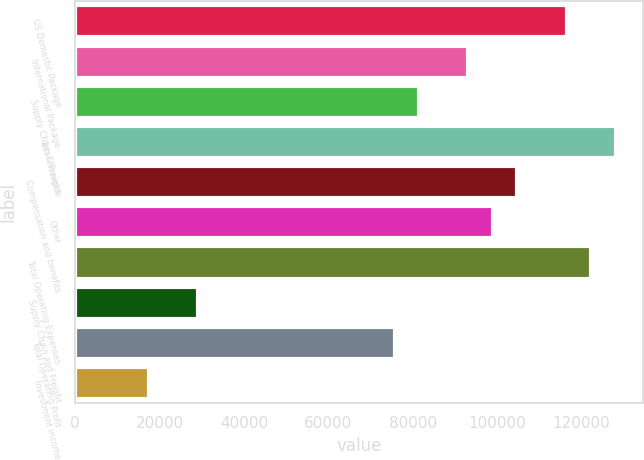Convert chart. <chart><loc_0><loc_0><loc_500><loc_500><bar_chart><fcel>US Domestic Package<fcel>International Package<fcel>Supply Chain & Freight<fcel>Total Revenue<fcel>Compensation and benefits<fcel>Other<fcel>Total Operating Expenses<fcel>Supply Chain and Freight<fcel>Total Operating Profit<fcel>Investment income<nl><fcel>116461<fcel>93169.6<fcel>81523.7<fcel>128107<fcel>104815<fcel>98992.5<fcel>122284<fcel>29117.3<fcel>75700.8<fcel>17471.5<nl></chart> 